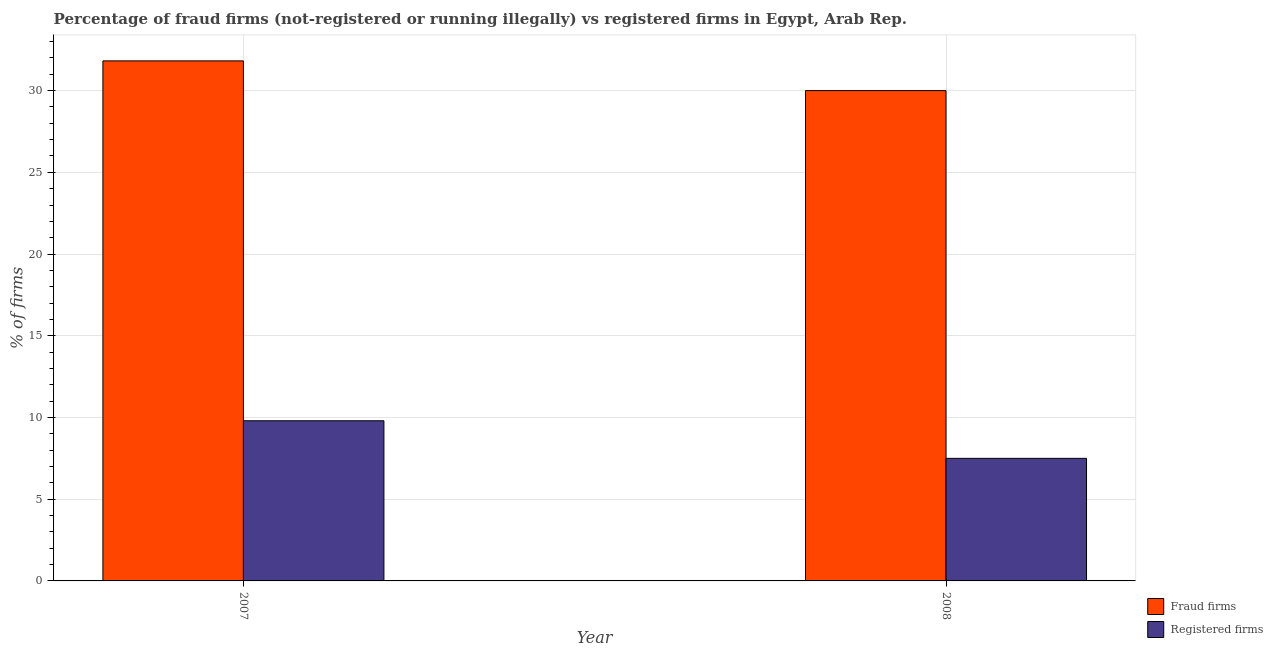Are the number of bars per tick equal to the number of legend labels?
Your answer should be very brief. Yes. Are the number of bars on each tick of the X-axis equal?
Make the answer very short. Yes. In how many cases, is the number of bars for a given year not equal to the number of legend labels?
Offer a terse response. 0. What is the percentage of fraud firms in 2008?
Make the answer very short. 30. What is the total percentage of fraud firms in the graph?
Make the answer very short. 61.82. What is the difference between the percentage of fraud firms in 2007 and that in 2008?
Ensure brevity in your answer.  1.82. What is the difference between the percentage of registered firms in 2008 and the percentage of fraud firms in 2007?
Give a very brief answer. -2.3. What is the average percentage of fraud firms per year?
Provide a succinct answer. 30.91. In the year 2008, what is the difference between the percentage of registered firms and percentage of fraud firms?
Your response must be concise. 0. What is the ratio of the percentage of fraud firms in 2007 to that in 2008?
Provide a succinct answer. 1.06. Is the percentage of registered firms in 2007 less than that in 2008?
Provide a short and direct response. No. In how many years, is the percentage of fraud firms greater than the average percentage of fraud firms taken over all years?
Your answer should be very brief. 1. What does the 2nd bar from the left in 2007 represents?
Offer a terse response. Registered firms. What does the 2nd bar from the right in 2008 represents?
Your response must be concise. Fraud firms. How many bars are there?
Provide a short and direct response. 4. What is the difference between two consecutive major ticks on the Y-axis?
Keep it short and to the point. 5. Does the graph contain any zero values?
Offer a very short reply. No. Does the graph contain grids?
Make the answer very short. Yes. How many legend labels are there?
Provide a succinct answer. 2. What is the title of the graph?
Ensure brevity in your answer.  Percentage of fraud firms (not-registered or running illegally) vs registered firms in Egypt, Arab Rep. What is the label or title of the X-axis?
Make the answer very short. Year. What is the label or title of the Y-axis?
Provide a succinct answer. % of firms. What is the % of firms of Fraud firms in 2007?
Ensure brevity in your answer.  31.82. What is the % of firms of Registered firms in 2008?
Keep it short and to the point. 7.5. Across all years, what is the maximum % of firms of Fraud firms?
Your response must be concise. 31.82. What is the total % of firms of Fraud firms in the graph?
Offer a very short reply. 61.82. What is the difference between the % of firms of Fraud firms in 2007 and that in 2008?
Ensure brevity in your answer.  1.82. What is the difference between the % of firms of Fraud firms in 2007 and the % of firms of Registered firms in 2008?
Provide a succinct answer. 24.32. What is the average % of firms of Fraud firms per year?
Your response must be concise. 30.91. What is the average % of firms of Registered firms per year?
Give a very brief answer. 8.65. In the year 2007, what is the difference between the % of firms in Fraud firms and % of firms in Registered firms?
Your answer should be very brief. 22.02. In the year 2008, what is the difference between the % of firms in Fraud firms and % of firms in Registered firms?
Offer a terse response. 22.5. What is the ratio of the % of firms in Fraud firms in 2007 to that in 2008?
Offer a very short reply. 1.06. What is the ratio of the % of firms of Registered firms in 2007 to that in 2008?
Ensure brevity in your answer.  1.31. What is the difference between the highest and the second highest % of firms in Fraud firms?
Your answer should be very brief. 1.82. What is the difference between the highest and the second highest % of firms in Registered firms?
Ensure brevity in your answer.  2.3. What is the difference between the highest and the lowest % of firms in Fraud firms?
Provide a succinct answer. 1.82. 